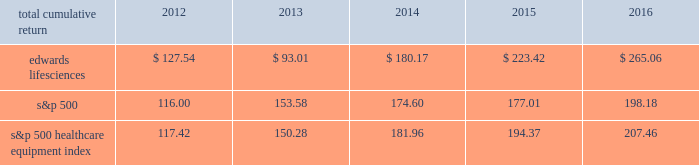2mar201707015999 ( c ) in october 2016 , our accelerated share repurchase ( 2018 2018asr 2019 2019 ) agreement concluded and we received an additional 44 thousand shares of our common stock .
Shares purchased pursuant to the asr agreement are presented in the table above in the periods in which they were received .
Performance graph the following graph compares the performance of our common stock with that of the s&p 500 index and the s&p 500 healthcare equipment index .
The cumulative total return listed below assumes an initial investment of $ 100 at the market close on december 30 , 2011 and reinvestment of dividends .
Comparison of 5 year cumulative total return 2011 2012 2016201520142013 edwards lifesciences corporation s&p 500 s&p 500 healthcare equipment index december 31 .

What was the difference in cumulative percentage returns between edwards lifesciences and the s&p 500 for the five years ended 2016? 
Computations: (((265.06 - 100) / 100) - ((198.18 - 100) / 100))
Answer: 0.6688. 